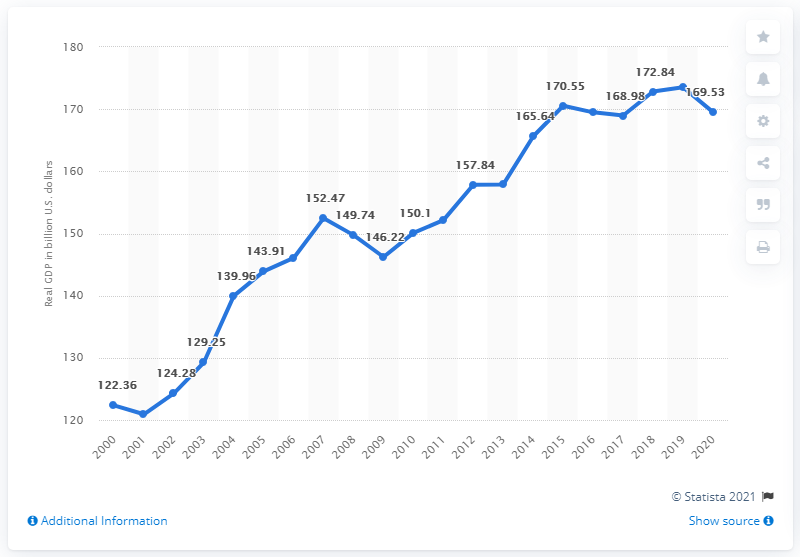List a handful of essential elements in this visual. In 2018, the estimated Gross Domestic Product (GDP) of the state of Iowa was 173.52 billion dollars. In 2020, the Gross Domestic Product (GDP) of Iowa was $169.53 billion. 